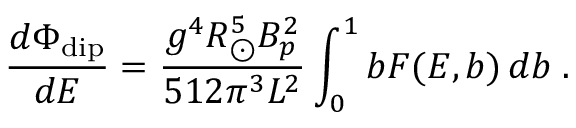<formula> <loc_0><loc_0><loc_500><loc_500>{ \frac { d \Phi _ { d i p } } { d E } } = { \frac { g ^ { 4 } R _ { \odot } ^ { 5 } B _ { p } ^ { 2 } } { 5 1 2 \pi ^ { 3 } L ^ { 2 } } } \int _ { 0 } ^ { 1 } b F ( E , b ) \, d b \, .</formula> 